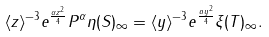<formula> <loc_0><loc_0><loc_500><loc_500>\| \langle z \rangle ^ { - 3 } e ^ { \frac { \alpha z ^ { 2 } } { 4 } } P ^ { \alpha } \eta ( S ) \| _ { \infty } = \| \langle y \rangle ^ { - 3 } e ^ { \frac { a y ^ { 2 } } { 4 } } \xi ( T ) \| _ { \infty } .</formula> 